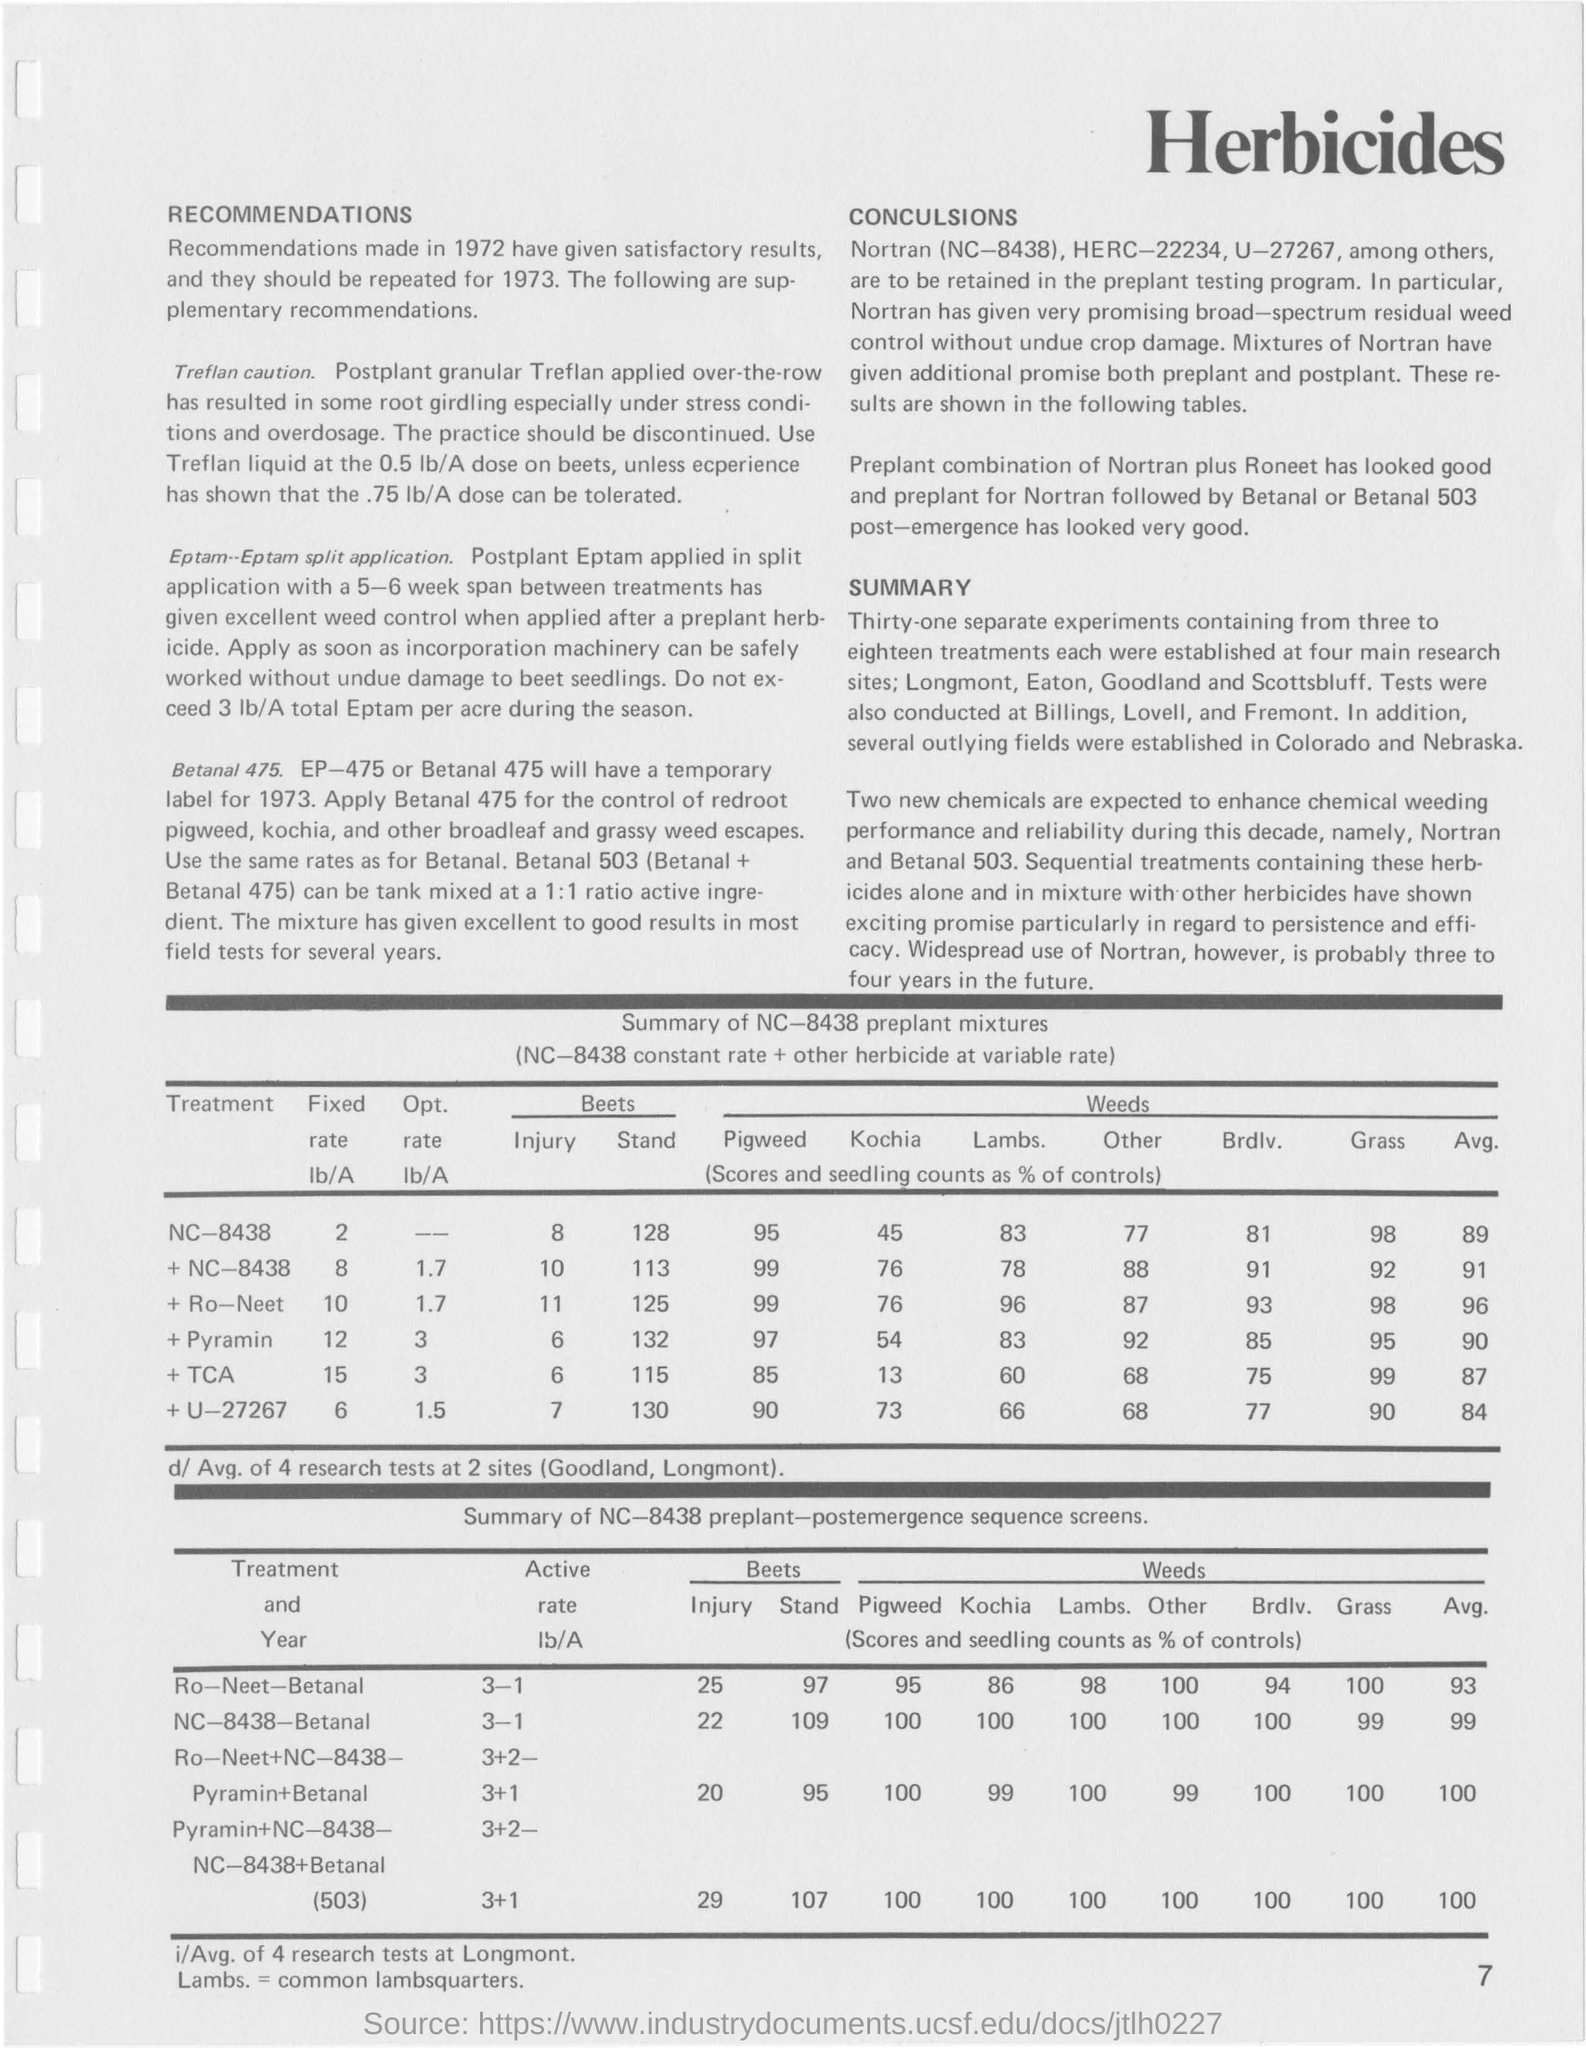Draw attention to some important aspects in this diagram. The following are the four main research sites: Longmont, Eaton, Goodland, and Scottsbluff. The title of the first table from the top is 'Summary of NC-8438 preplant mixtures.' The fixed rate for the treatment NC-8438 is 2. The second table from the top is titled "Summary of NC-8438 preplant-postemergence sequence screens.". In 1973, a temporary label will be used for a medication known as EP-475 or Betanal 475. 